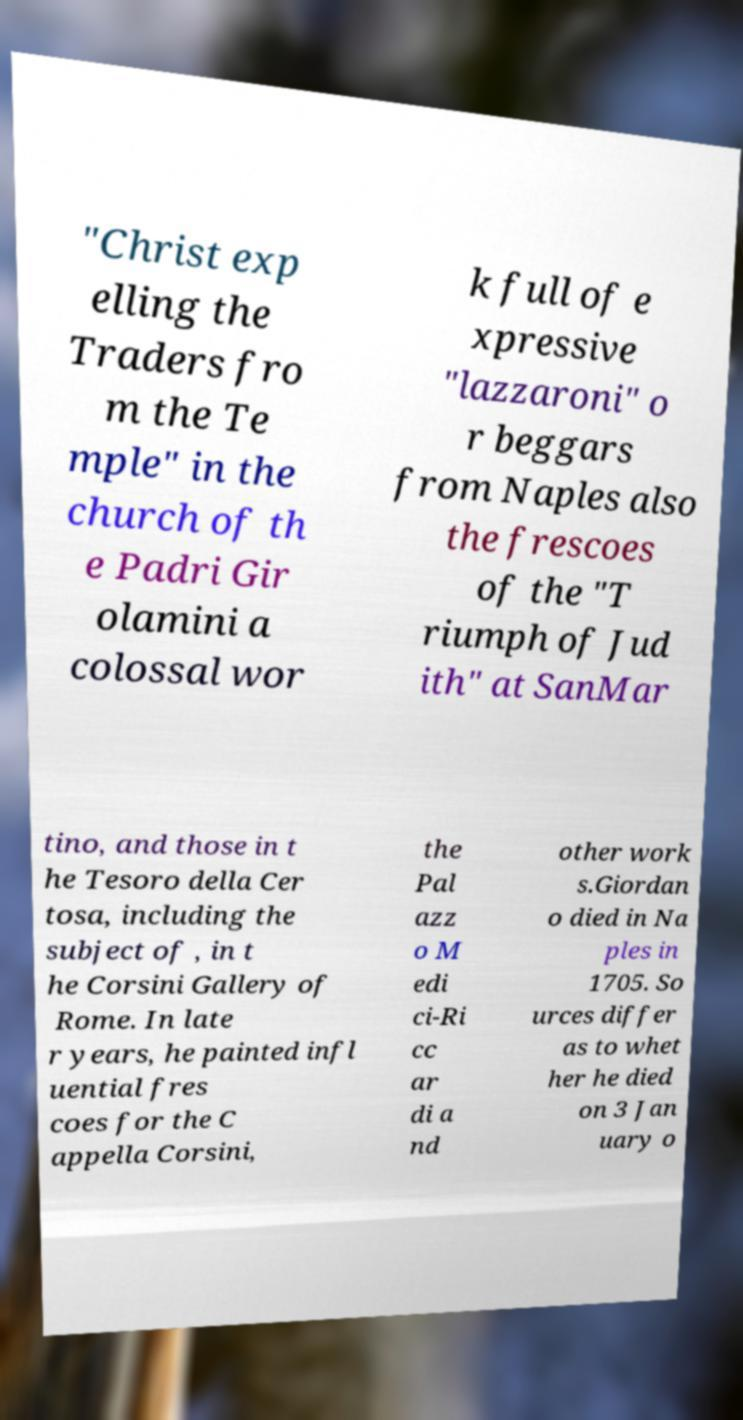Please identify and transcribe the text found in this image. "Christ exp elling the Traders fro m the Te mple" in the church of th e Padri Gir olamini a colossal wor k full of e xpressive "lazzaroni" o r beggars from Naples also the frescoes of the "T riumph of Jud ith" at SanMar tino, and those in t he Tesoro della Cer tosa, including the subject of , in t he Corsini Gallery of Rome. In late r years, he painted infl uential fres coes for the C appella Corsini, the Pal azz o M edi ci-Ri cc ar di a nd other work s.Giordan o died in Na ples in 1705. So urces differ as to whet her he died on 3 Jan uary o 